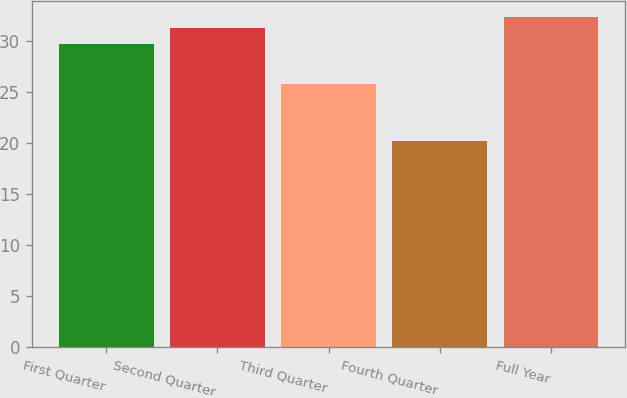Convert chart. <chart><loc_0><loc_0><loc_500><loc_500><bar_chart><fcel>First Quarter<fcel>Second Quarter<fcel>Third Quarter<fcel>Fourth Quarter<fcel>Full Year<nl><fcel>29.63<fcel>31.19<fcel>25.79<fcel>20.18<fcel>32.29<nl></chart> 